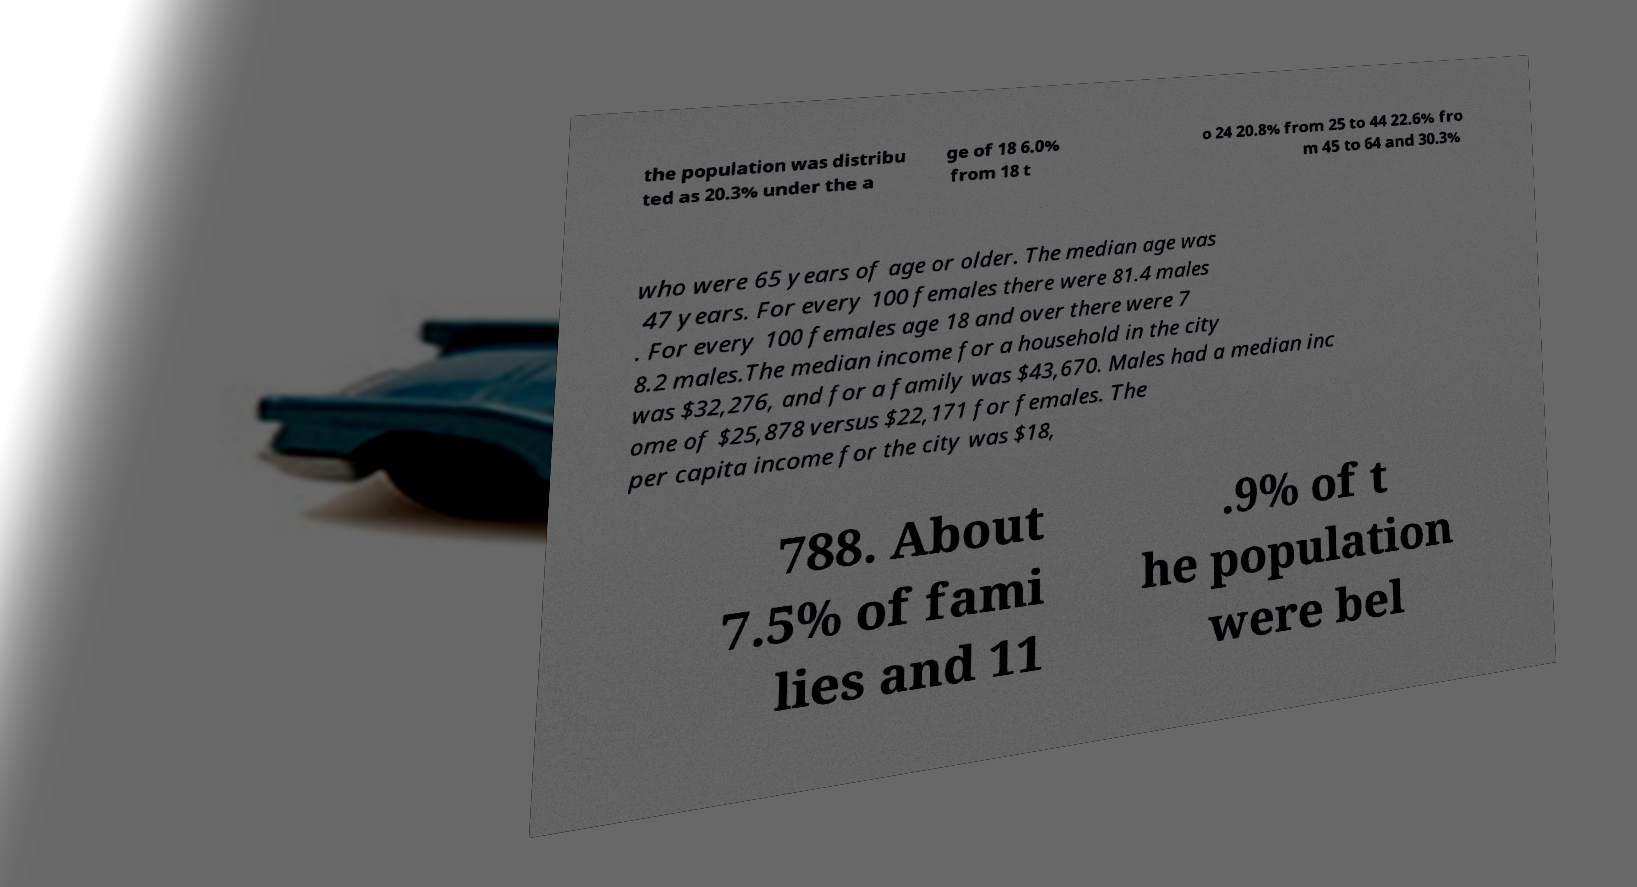Please read and relay the text visible in this image. What does it say? the population was distribu ted as 20.3% under the a ge of 18 6.0% from 18 t o 24 20.8% from 25 to 44 22.6% fro m 45 to 64 and 30.3% who were 65 years of age or older. The median age was 47 years. For every 100 females there were 81.4 males . For every 100 females age 18 and over there were 7 8.2 males.The median income for a household in the city was $32,276, and for a family was $43,670. Males had a median inc ome of $25,878 versus $22,171 for females. The per capita income for the city was $18, 788. About 7.5% of fami lies and 11 .9% of t he population were bel 